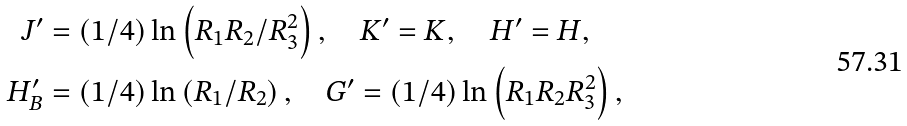<formula> <loc_0><loc_0><loc_500><loc_500>J ^ { \prime } & = ( 1 / 4 ) \ln \left ( R _ { 1 } R _ { 2 } / R _ { 3 } ^ { 2 } \right ) , \quad K ^ { \prime } = K , \quad H ^ { \prime } = H , \\ H _ { B } ^ { \prime } & = ( 1 / 4 ) \ln \left ( R _ { 1 } / R _ { 2 } \right ) , \quad G ^ { \prime } = ( 1 / 4 ) \ln \left ( R _ { 1 } R _ { 2 } R _ { 3 } ^ { 2 } \right ) ,</formula> 